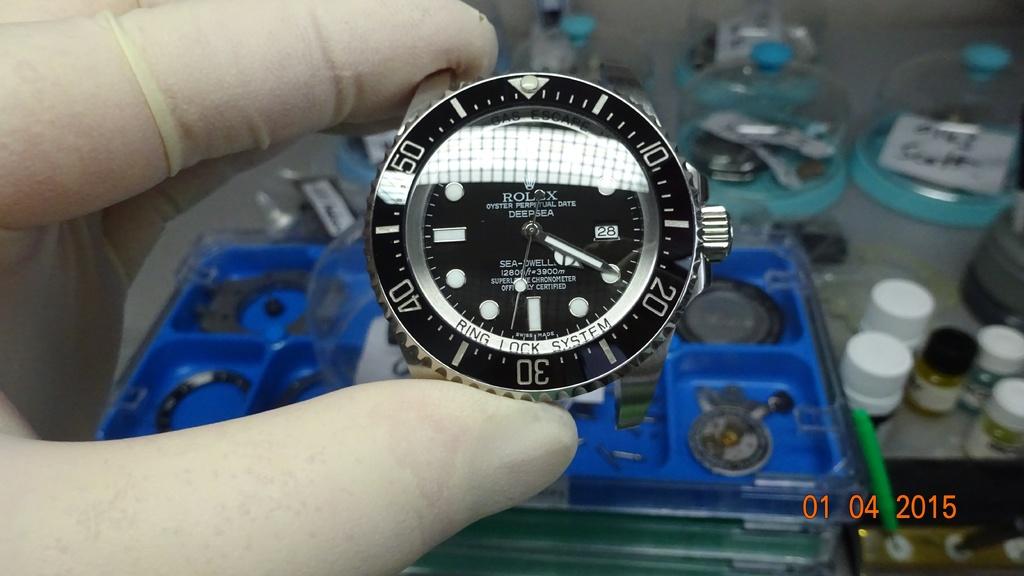What is the date stamp on the photo?
Provide a short and direct response. 01 04 2015. 